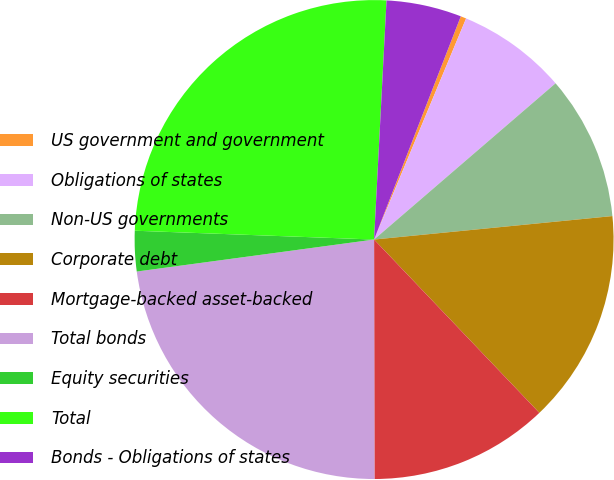Convert chart. <chart><loc_0><loc_0><loc_500><loc_500><pie_chart><fcel>US government and government<fcel>Obligations of states<fcel>Non-US governments<fcel>Corporate debt<fcel>Mortgage-backed asset-backed<fcel>Total bonds<fcel>Equity securities<fcel>Total<fcel>Bonds - Obligations of states<nl><fcel>0.38%<fcel>7.41%<fcel>9.75%<fcel>14.44%<fcel>12.1%<fcel>22.89%<fcel>2.72%<fcel>25.24%<fcel>5.07%<nl></chart> 